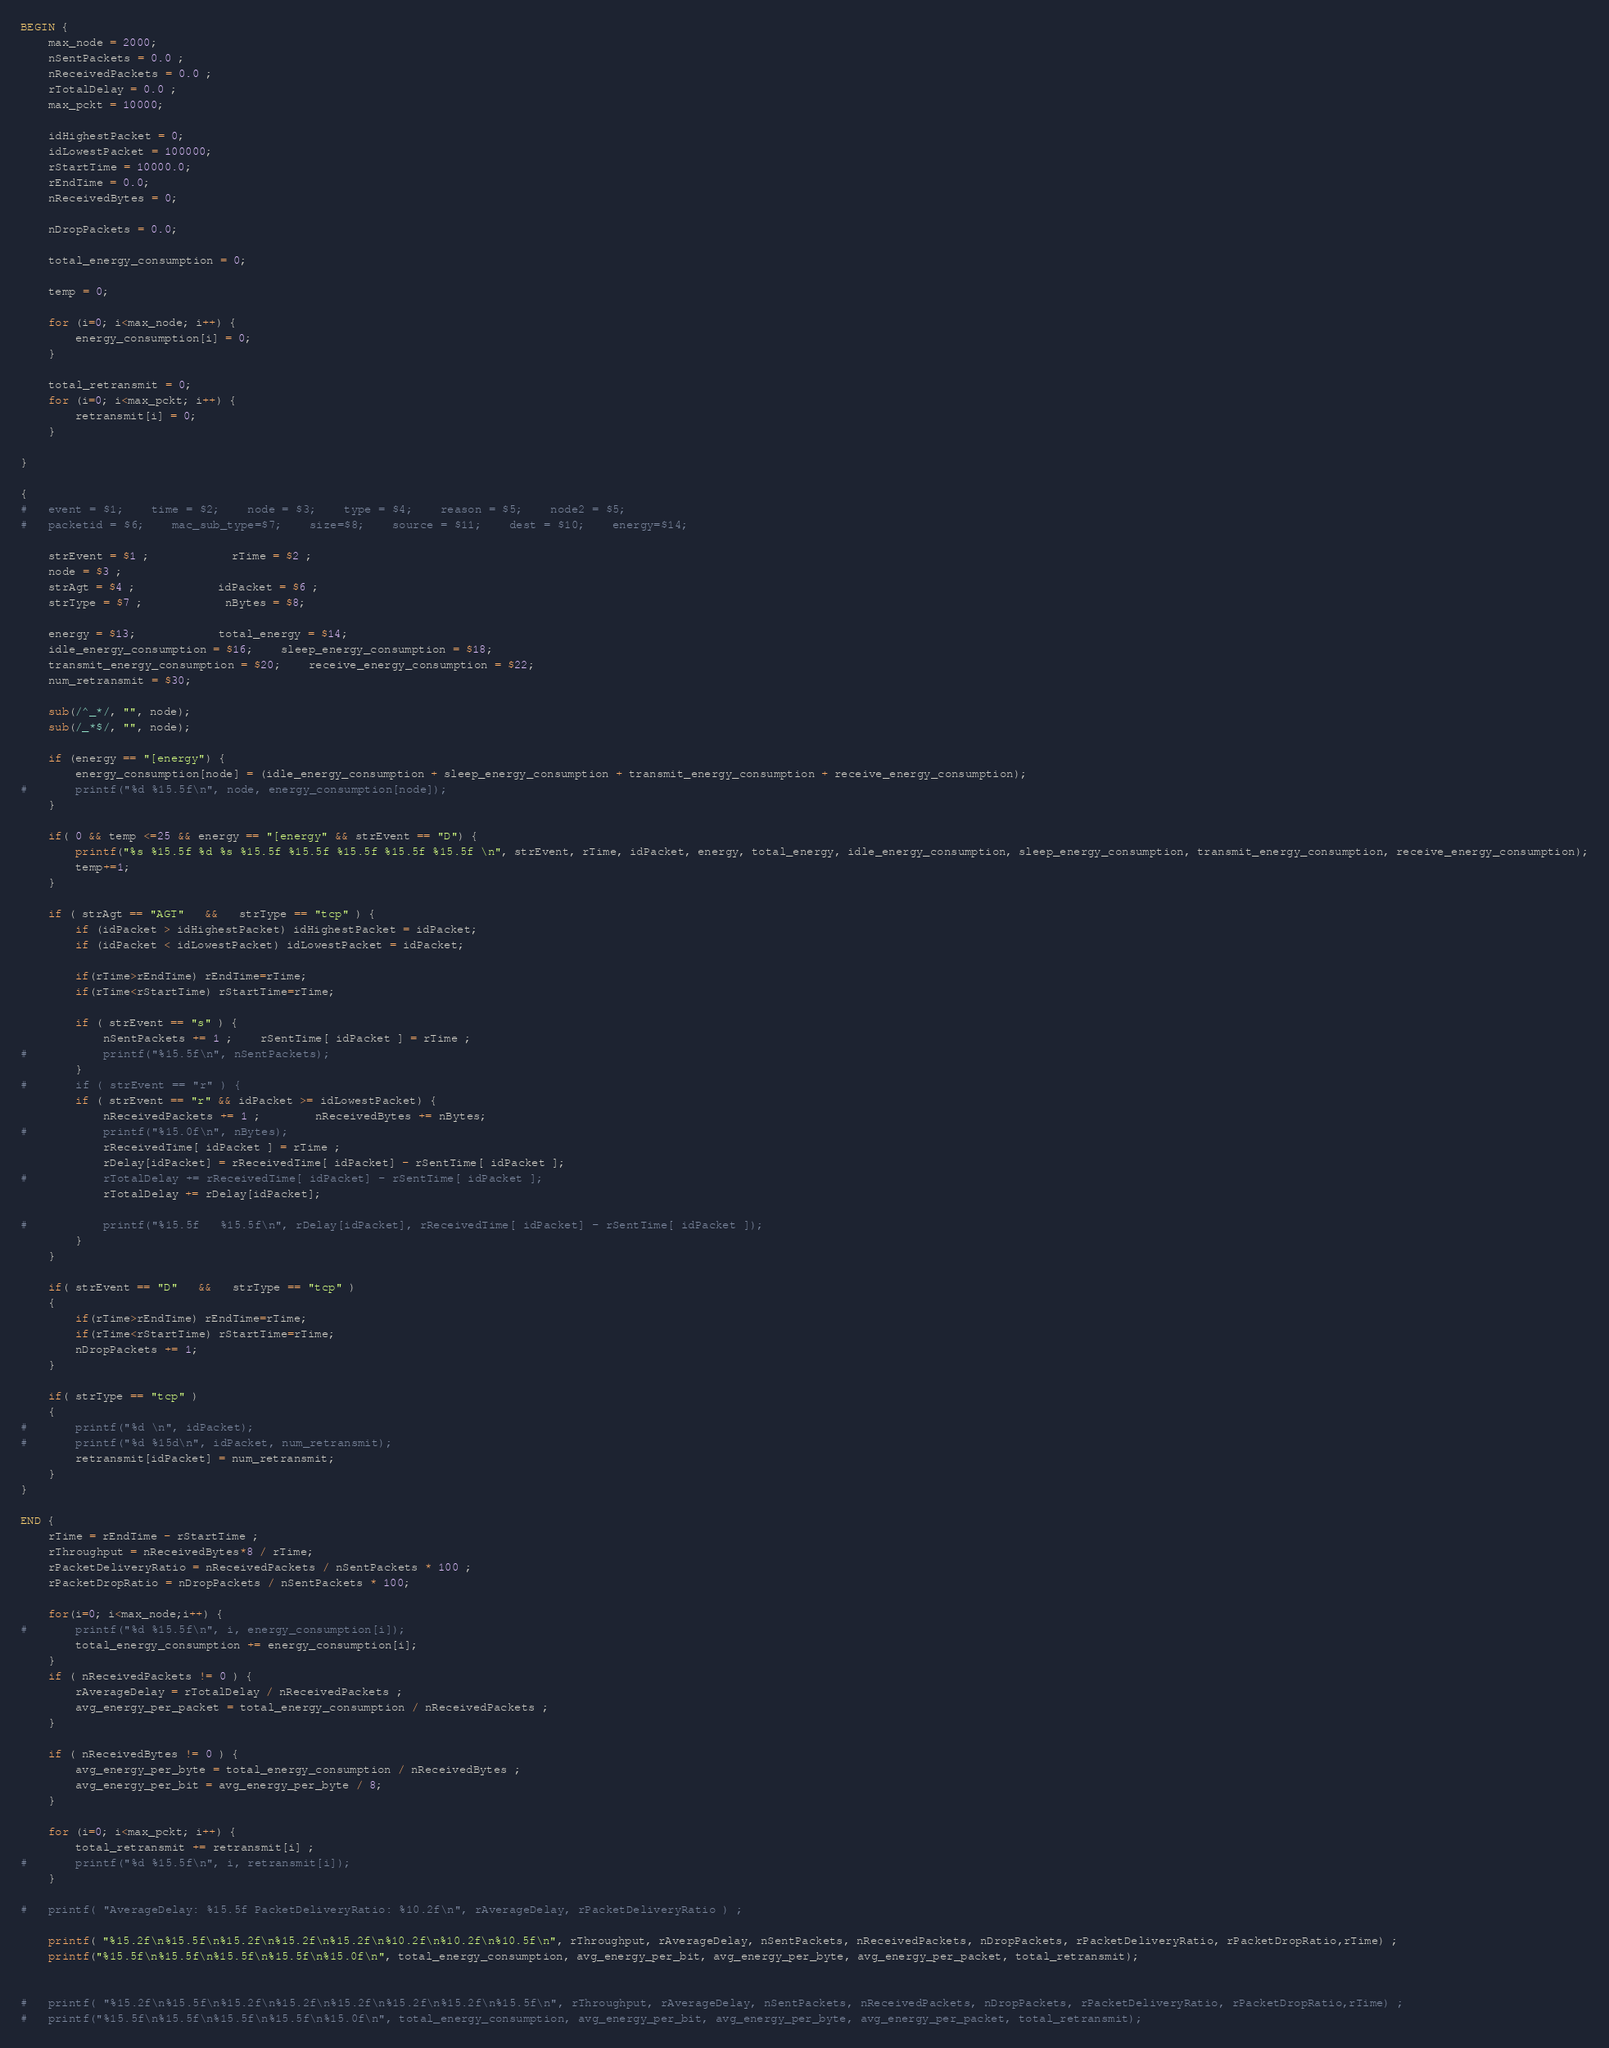<code> <loc_0><loc_0><loc_500><loc_500><_Awk_>BEGIN {
	max_node = 2000;
	nSentPackets = 0.0 ;		
	nReceivedPackets = 0.0 ;
	rTotalDelay = 0.0 ;
	max_pckt = 10000;
	
	idHighestPacket = 0;
	idLowestPacket = 100000;
	rStartTime = 10000.0;
	rEndTime = 0.0;
	nReceivedBytes = 0;

	nDropPackets = 0.0;

	total_energy_consumption = 0;

	temp = 0;
	
	for (i=0; i<max_node; i++) {
		energy_consumption[i] = 0;		
	}

	total_retransmit = 0;
	for (i=0; i<max_pckt; i++) {
		retransmit[i] = 0;		
	}

}

{
#	event = $1;    time = $2;    node = $3;    type = $4;    reason = $5;    node2 = $5;    
#	packetid = $6;    mac_sub_type=$7;    size=$8;    source = $11;    dest = $10;    energy=$14;

	strEvent = $1 ;			rTime = $2 ;
	node = $3 ;
	strAgt = $4 ;			idPacket = $6 ;
	strType = $7 ;			nBytes = $8;

	energy = $13;			total_energy = $14;
	idle_energy_consumption = $16;	sleep_energy_consumption = $18; 
	transmit_energy_consumption = $20;	receive_energy_consumption = $22; 
	num_retransmit = $30;
	
	sub(/^_*/, "", node);
	sub(/_*$/, "", node);

	if (energy == "[energy") {
		energy_consumption[node] = (idle_energy_consumption + sleep_energy_consumption + transmit_energy_consumption + receive_energy_consumption);
#		printf("%d %15.5f\n", node, energy_consumption[node]);
	}

	if( 0 && temp <=25 && energy == "[energy" && strEvent == "D") {
		printf("%s %15.5f %d %s %15.5f %15.5f %15.5f %15.5f %15.5f \n", strEvent, rTime, idPacket, energy, total_energy, idle_energy_consumption, sleep_energy_consumption, transmit_energy_consumption, receive_energy_consumption);
		temp+=1;
	}

	if ( strAgt == "AGT"   &&   strType == "tcp" ) {
		if (idPacket > idHighestPacket) idHighestPacket = idPacket;
		if (idPacket < idLowestPacket) idLowestPacket = idPacket;

		if(rTime>rEndTime) rEndTime=rTime;
		if(rTime<rStartTime) rStartTime=rTime;

		if ( strEvent == "s" ) {
			nSentPackets += 1 ;	rSentTime[ idPacket ] = rTime ;
#			printf("%15.5f\n", nSentPackets);
		}
#		if ( strEvent == "r" ) {
		if ( strEvent == "r" && idPacket >= idLowestPacket) {
			nReceivedPackets += 1 ;		nReceivedBytes += nBytes;
#			printf("%15.0f\n", nBytes);
			rReceivedTime[ idPacket ] = rTime ;
			rDelay[idPacket] = rReceivedTime[ idPacket] - rSentTime[ idPacket ];
#			rTotalDelay += rReceivedTime[ idPacket] - rSentTime[ idPacket ];
			rTotalDelay += rDelay[idPacket]; 

#			printf("%15.5f   %15.5f\n", rDelay[idPacket], rReceivedTime[ idPacket] - rSentTime[ idPacket ]);
		}
	}

	if( strEvent == "D"   &&   strType == "tcp" )
	{
		if(rTime>rEndTime) rEndTime=rTime;
		if(rTime<rStartTime) rStartTime=rTime;
		nDropPackets += 1;
	}

	if( strType == "tcp" )
	{
#		printf("%d \n", idPacket);
#		printf("%d %15d\n", idPacket, num_retransmit);
		retransmit[idPacket] = num_retransmit;		
	}
}

END {
	rTime = rEndTime - rStartTime ;
	rThroughput = nReceivedBytes*8 / rTime;
	rPacketDeliveryRatio = nReceivedPackets / nSentPackets * 100 ;
	rPacketDropRatio = nDropPackets / nSentPackets * 100;

	for(i=0; i<max_node;i++) {
#		printf("%d %15.5f\n", i, energy_consumption[i]);
		total_energy_consumption += energy_consumption[i];
	}
	if ( nReceivedPackets != 0 ) {
		rAverageDelay = rTotalDelay / nReceivedPackets ;
		avg_energy_per_packet = total_energy_consumption / nReceivedPackets ;
	}

	if ( nReceivedBytes != 0 ) {
		avg_energy_per_byte = total_energy_consumption / nReceivedBytes ;
		avg_energy_per_bit = avg_energy_per_byte / 8;
	}

	for (i=0; i<max_pckt; i++) {
		total_retransmit += retransmit[i] ;		
#		printf("%d %15.5f\n", i, retransmit[i]);
	}

#	printf( "AverageDelay: %15.5f PacketDeliveryRatio: %10.2f\n", rAverageDelay, rPacketDeliveryRatio ) ;

	printf( "%15.2f\n%15.5f\n%15.2f\n%15.2f\n%15.2f\n%10.2f\n%10.2f\n%10.5f\n", rThroughput, rAverageDelay, nSentPackets, nReceivedPackets, nDropPackets, rPacketDeliveryRatio, rPacketDropRatio,rTime) ;
	printf("%15.5f\n%15.5f\n%15.5f\n%15.5f\n%15.0f\n", total_energy_consumption, avg_energy_per_bit, avg_energy_per_byte, avg_energy_per_packet, total_retransmit);


#	printf( "%15.2f\n%15.5f\n%15.2f\n%15.2f\n%15.2f\n%15.2f\n%15.2f\n%15.5f\n", rThroughput, rAverageDelay, nSentPackets, nReceivedPackets, nDropPackets, rPacketDeliveryRatio, rPacketDropRatio,rTime) ;
#	printf("%15.5f\n%15.5f\n%15.5f\n%15.5f\n%15.0f\n", total_energy_consumption, avg_energy_per_bit, avg_energy_per_byte, avg_energy_per_packet, total_retransmit);

</code> 